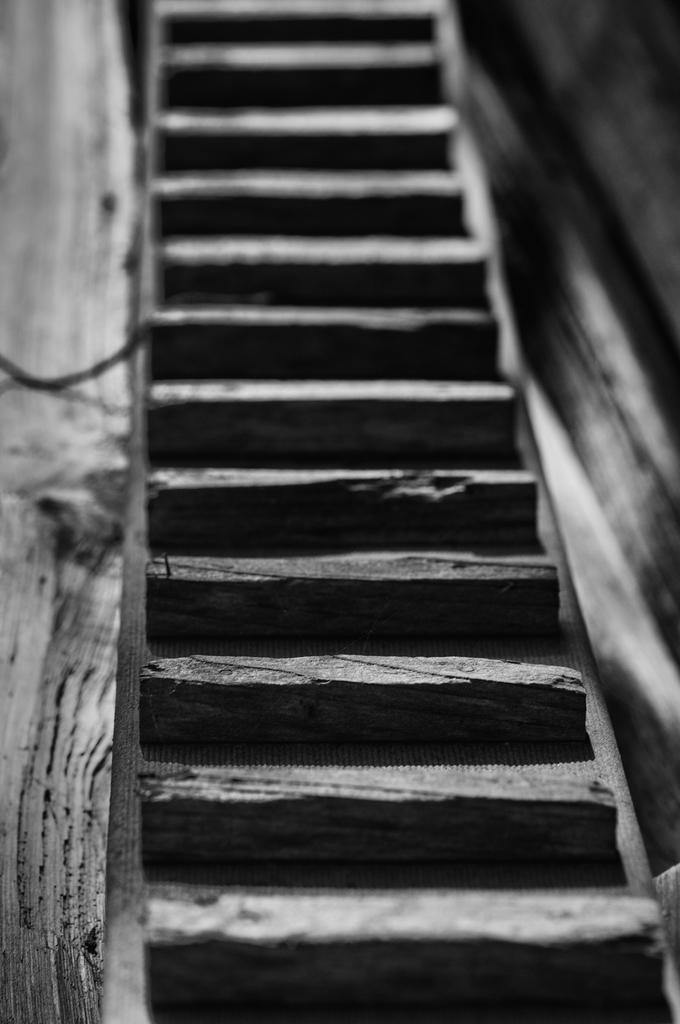What type of architectural feature is present in the image? There are stairs in the image. What color scheme is used in the image? The image is in black and white. How many pets are visible in the jar in the image? There is no jar or pets present in the image. What time of day is depicted in the image? The image does not provide any information about the time of day, as it is in black and white and does not include any clocks or other time-related objects. 